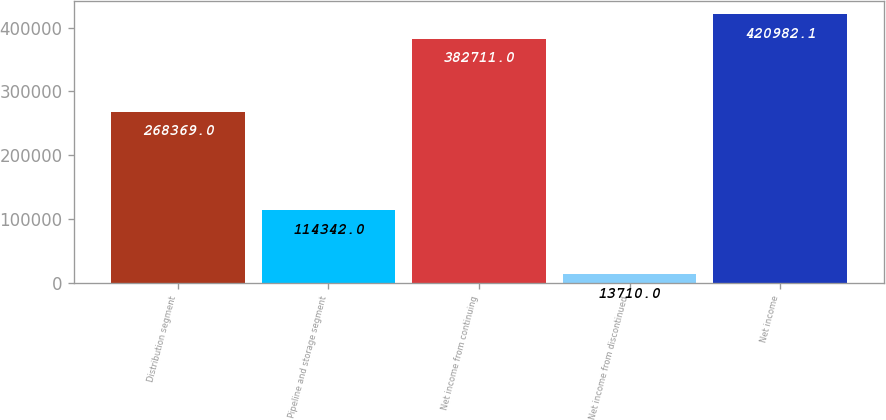<chart> <loc_0><loc_0><loc_500><loc_500><bar_chart><fcel>Distribution segment<fcel>Pipeline and storage segment<fcel>Net income from continuing<fcel>Net income from discontinued<fcel>Net income<nl><fcel>268369<fcel>114342<fcel>382711<fcel>13710<fcel>420982<nl></chart> 